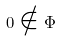<formula> <loc_0><loc_0><loc_500><loc_500>0 \notin \Phi</formula> 